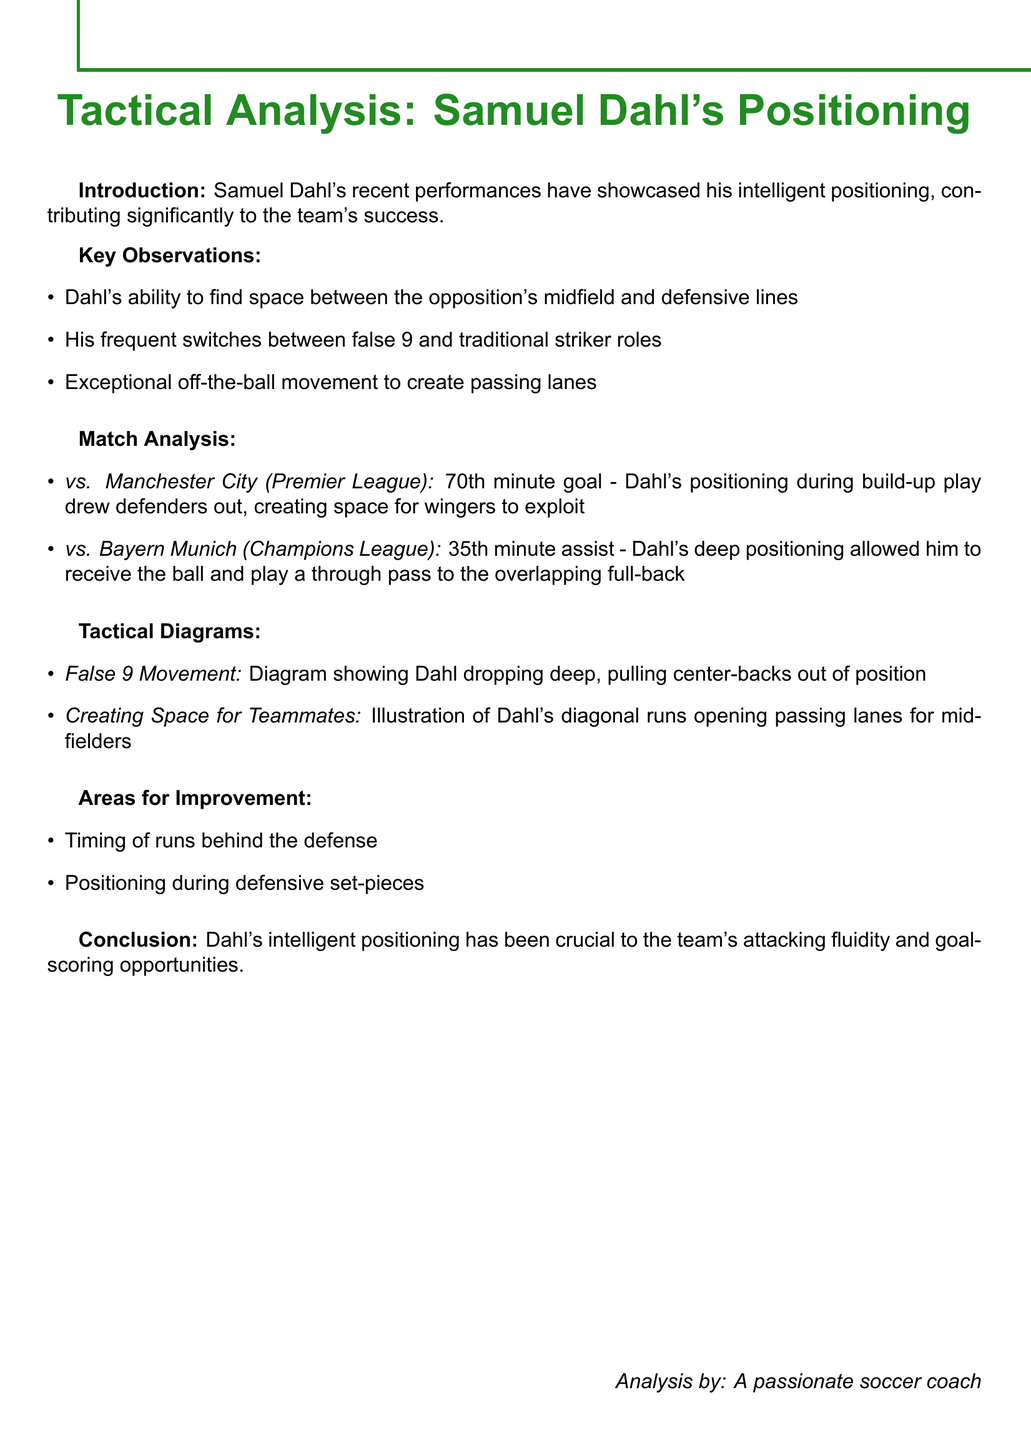What is the title of the document? The title of the document is clearly stated at the beginning.
Answer: Tactical Analysis: Samuel Dahl's Positioning What is one key observation about Samuel Dahl? The document lists multiple observations; one example can be highlighted.
Answer: Dahl's ability to find space between the opposition's midfield and defensive lines In which match did Dahl score a goal in the 70th minute? The match analysis section specifies the matches and events.
Answer: vs. Manchester City (Premier League) How many areas for improvement are listed? The section on areas for improvement states how many specific areas are mentioned.
Answer: 2 What role does Dahl frequently switch between? This information is found in the key observations section of the document.
Answer: False 9 and traditional striker roles Which minute did Dahl provide an assist against Bayern Munich? The document details the timing of key plays in the match analysis.
Answer: 35th minute What type of diagram illustrates Dahl's diagonal runs? The tactical diagrams section indicates the focus of the illustrations.
Answer: Creating Space for Teammates What is a noted area for improvement related to defensive actions? The list of areas for improvement mentions specific aspects of Dahl's game.
Answer: Positioning during defensive set-pieces Who authored the analysis? The authorship of the document is provided at the end.
Answer: A passionate soccer coach 